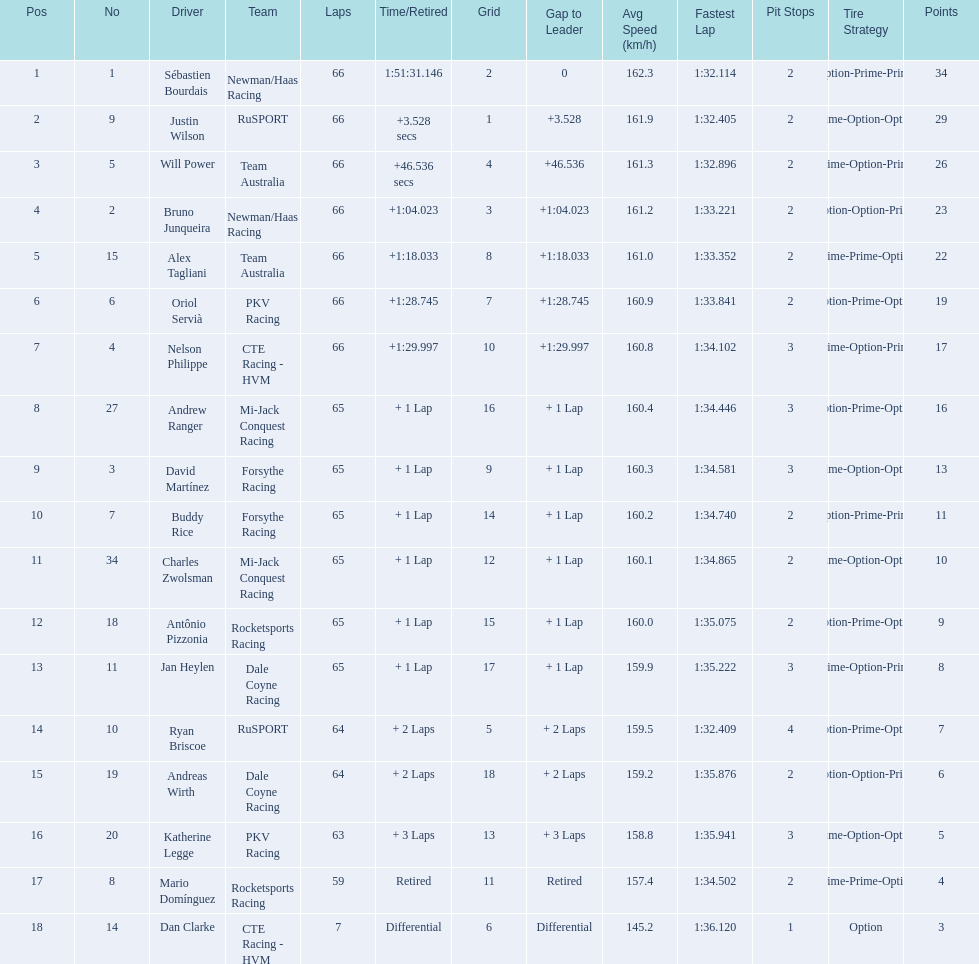How many points did first place receive? 34. How many did last place receive? 3. Who was the recipient of these last place points? Dan Clarke. 